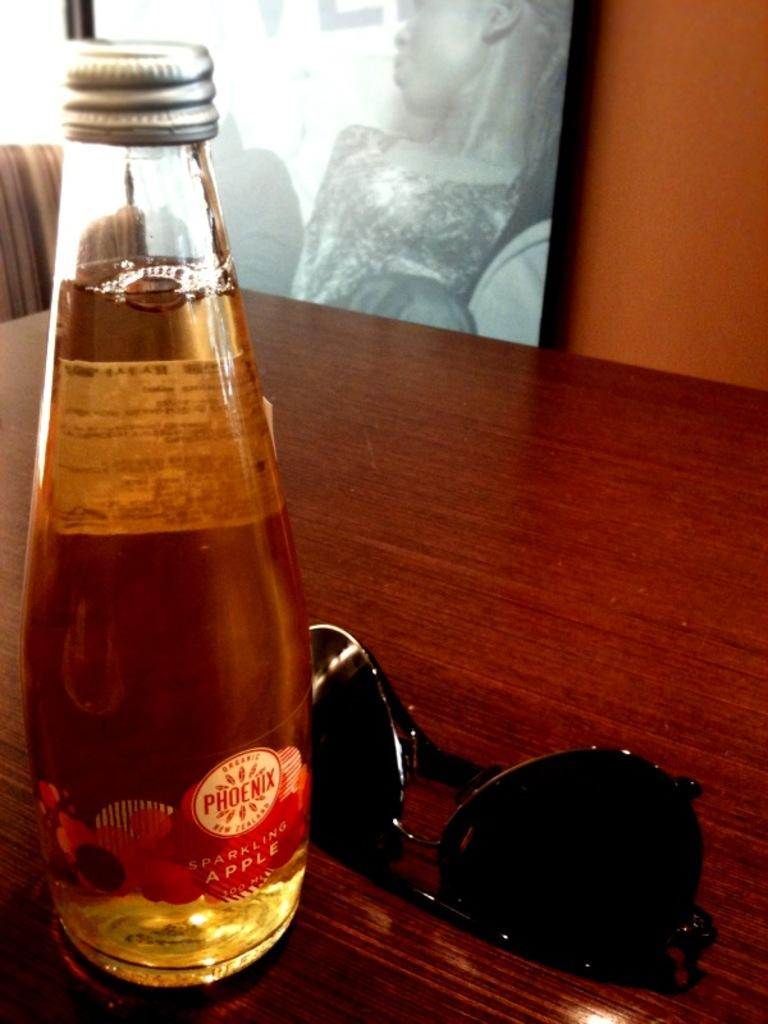<image>
Relay a brief, clear account of the picture shown. A bottle of Phoenix Sparkling Apple on a table next to a pair of sunglasses. 